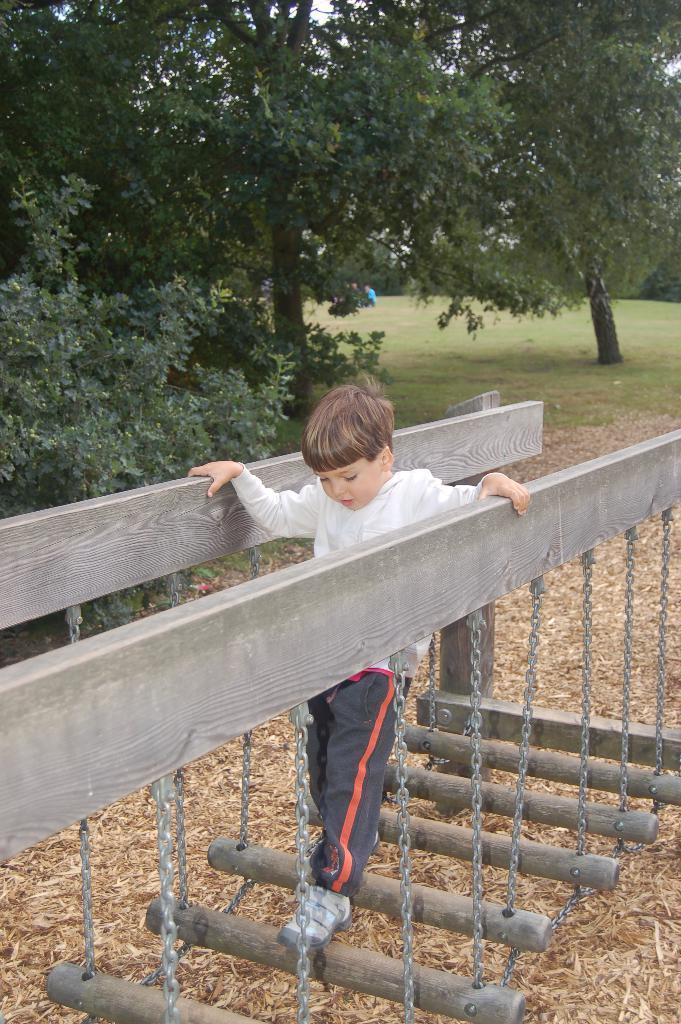In one or two sentences, can you explain what this image depicts? In this image I can see a boy standing on a wooden way with chains I can see trees behind him on the ground with grass. 